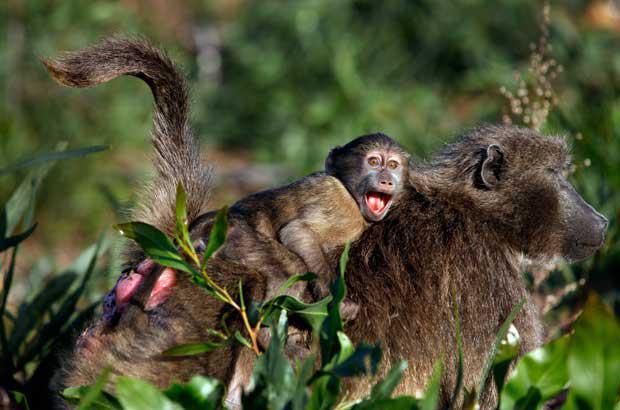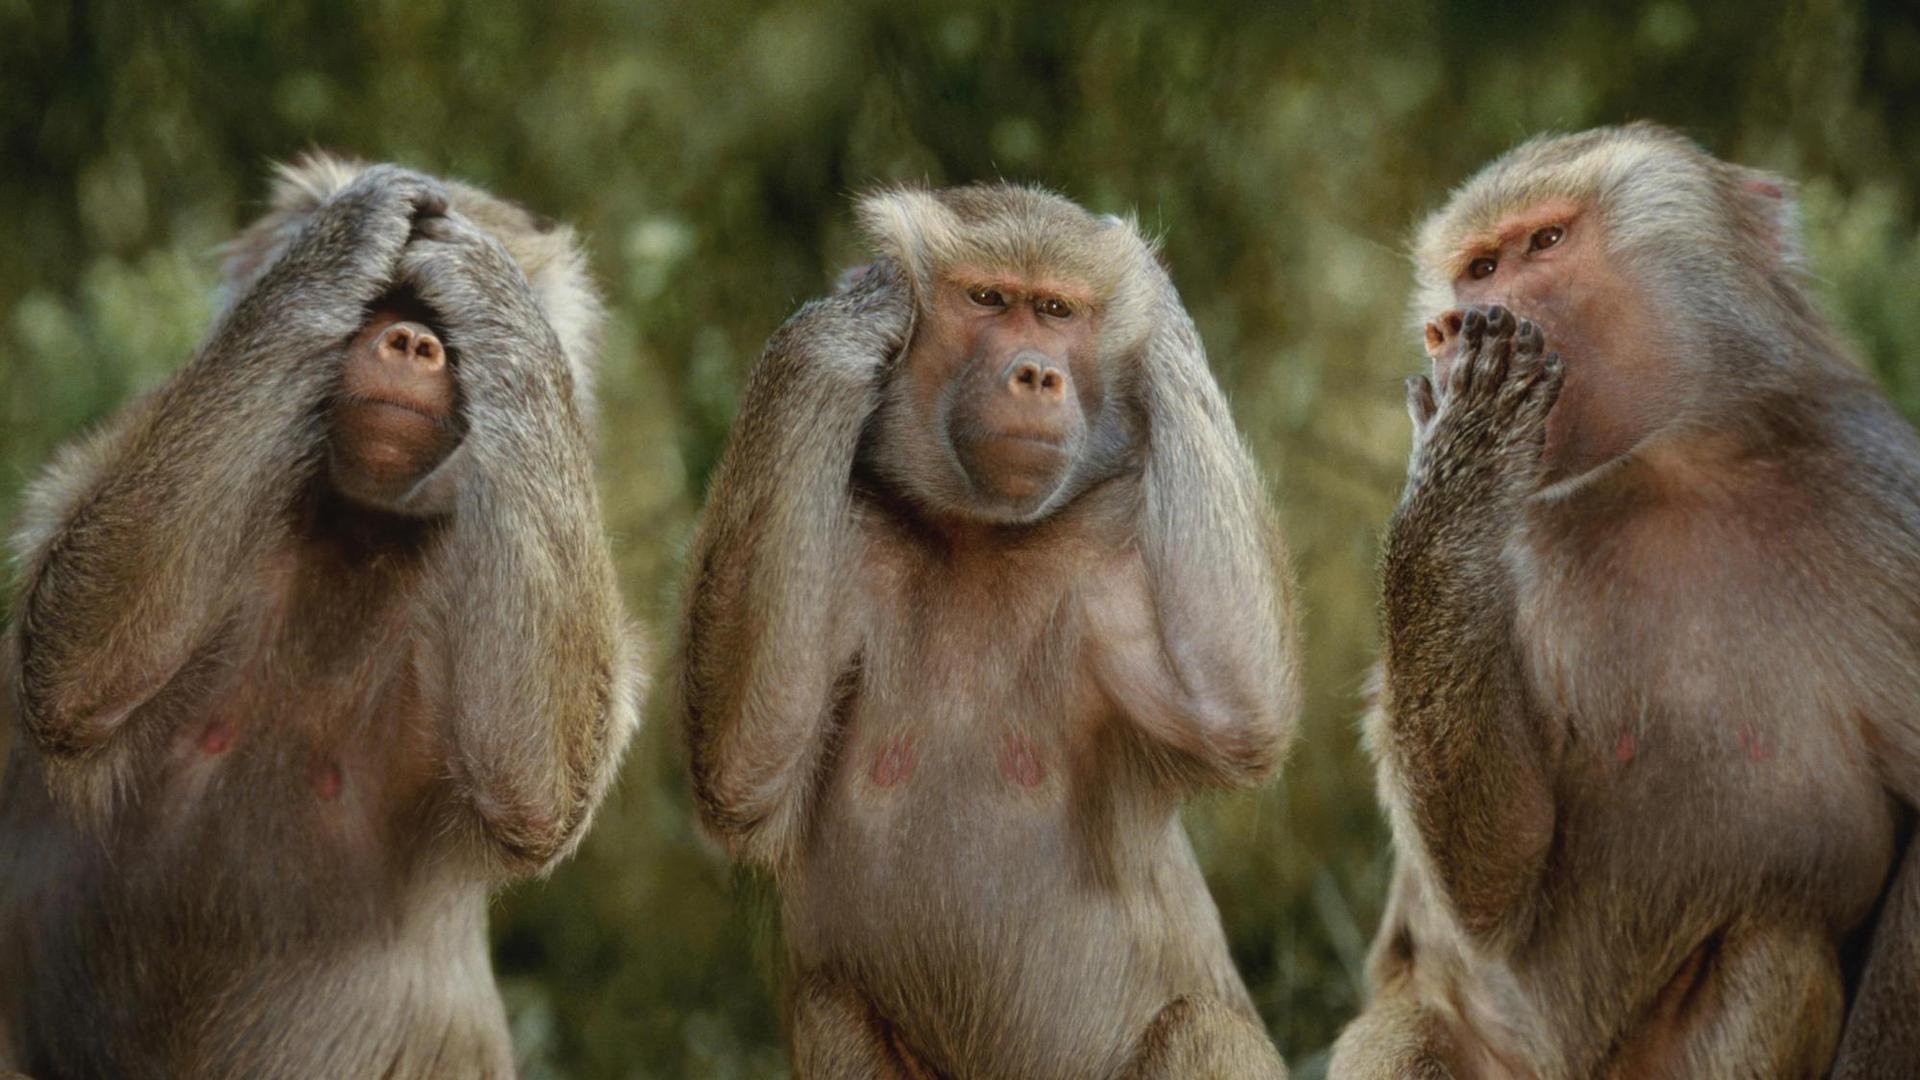The first image is the image on the left, the second image is the image on the right. For the images displayed, is the sentence "there are three monkeys in the image to the right." factually correct? Answer yes or no. Yes. The first image is the image on the left, the second image is the image on the right. For the images shown, is this caption "The left image contains exactly one primate." true? Answer yes or no. No. 